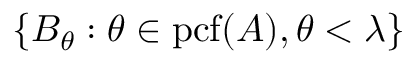Convert formula to latex. <formula><loc_0><loc_0><loc_500><loc_500>\{ B _ { \theta } \colon \theta \in { p c f } ( A ) , \theta < \lambda \}</formula> 